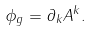Convert formula to latex. <formula><loc_0><loc_0><loc_500><loc_500>\phi _ { g } = \partial _ { k } A ^ { k } .</formula> 